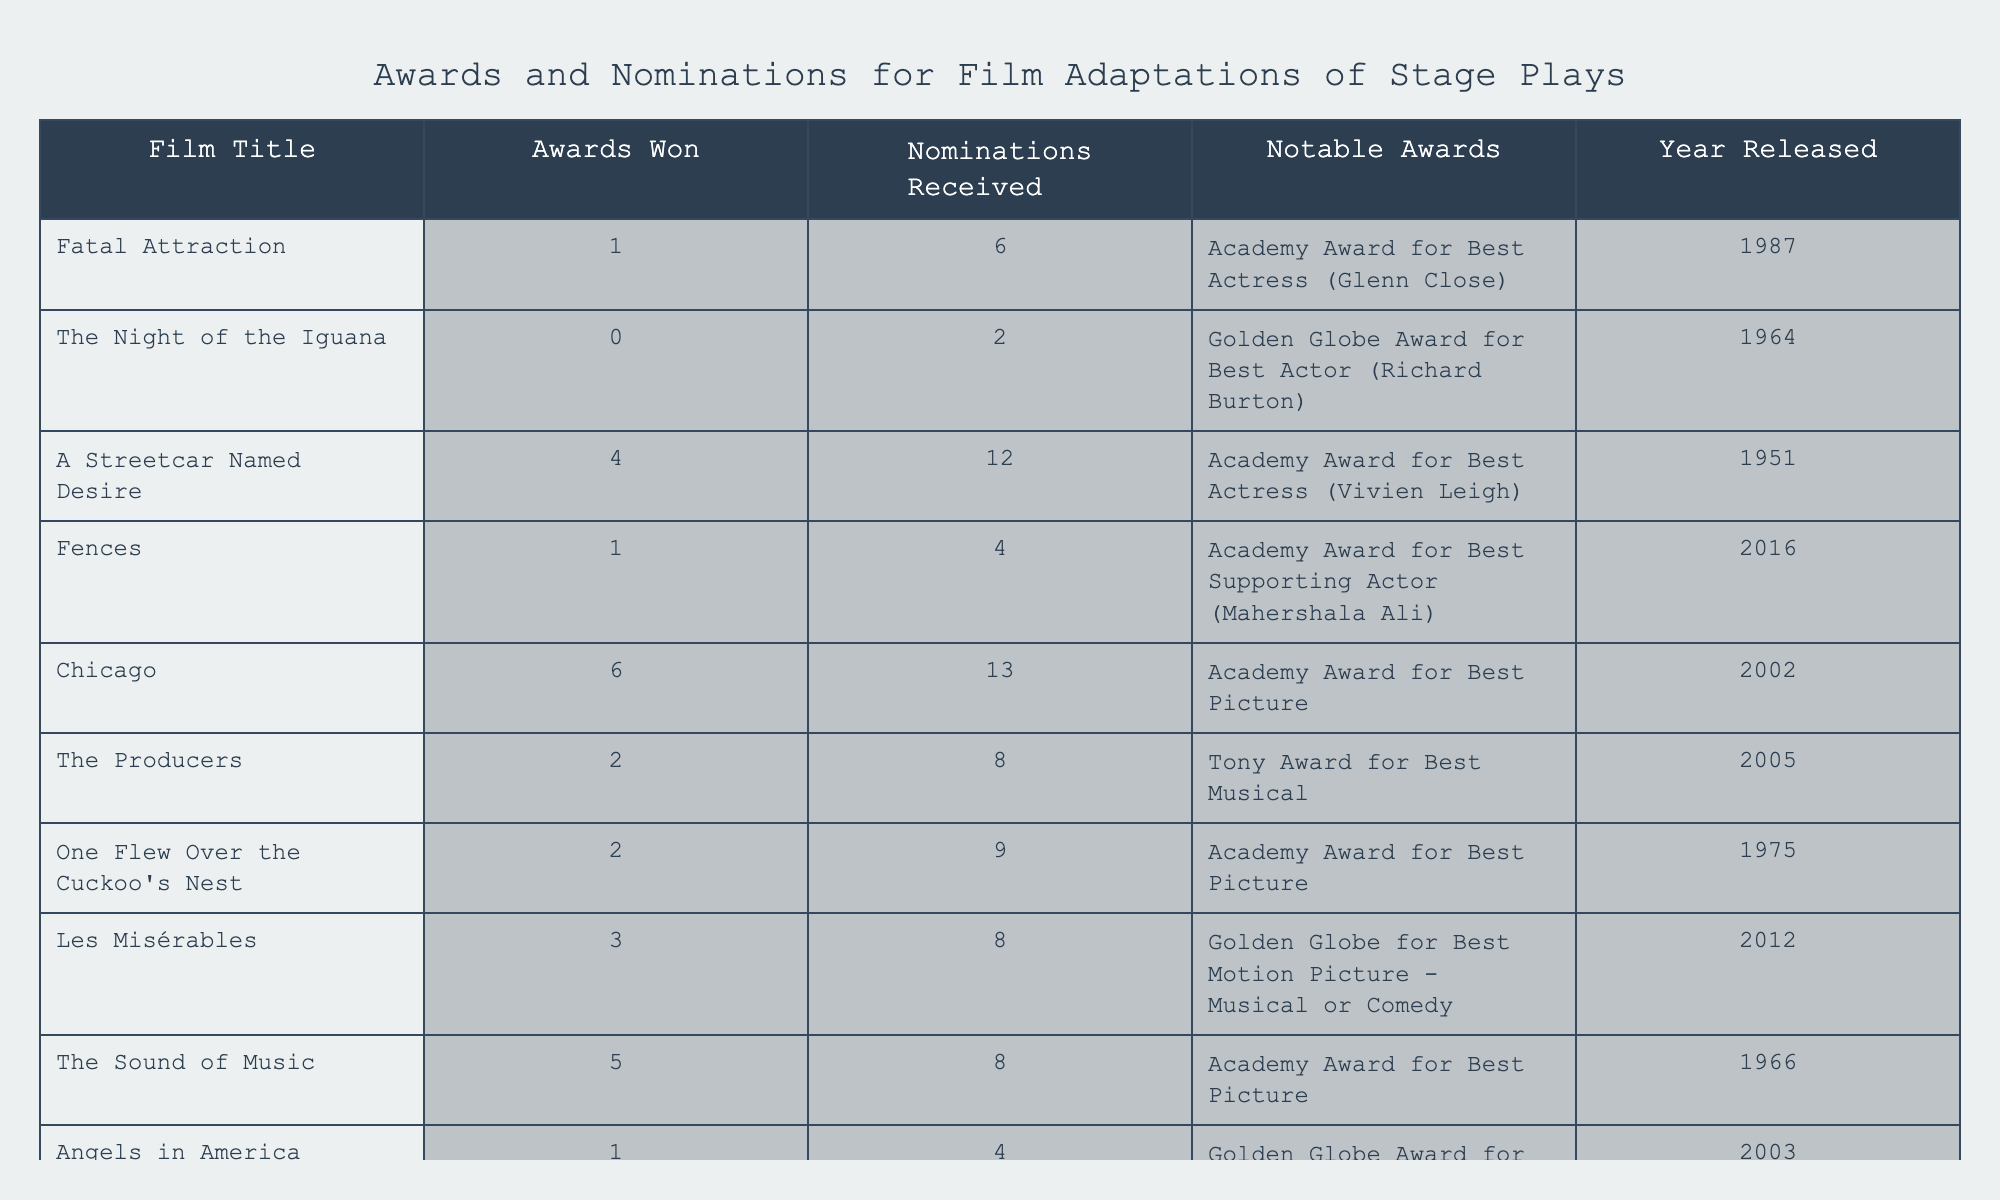What film adaptation has the most awards won? By examining the "Awards Won" column, "Chicago" has won the highest number with 6 awards.
Answer: Chicago Which film adaptation received an Academy Award for Best Actress? Looking at the "Notable Awards" column, "A Streetcar Named Desire" with Vivien Leigh is the only film adaptation that received this specific award.
Answer: A Streetcar Named Desire What is the total number of nominations received by the films listed? Adding the "Nominations Received" together: 6 + 2 + 12 + 4 + 13 + 8 + 9 + 8 + 8 + 4 = 76.
Answer: 76 Did "Les Misérables" win any awards? Referring to the "Awards Won", "Les Misérables" shows 3 awards won, which means it did win awards.
Answer: Yes Which film adaptations received a total of 4 nominations or fewer? By evaluating the "Nominations Received" column, we find "The Night of the Iguana" (2), "Fences" (4), and "Angels in America" (4), totaling three films fitting this criteria.
Answer: 3 What is the ratio of awards won to nominations received for "Fatal Attraction"? The ratio for "Fatal Attraction" is calculated as 1 award won to 6 nominations received, which simplifies to 1:6.
Answer: 1:6 Which film had the greatest number of nominations without winning any awards? "The Night of the Iguana" had 2 nominations and did not win any awards, making it the film with the greatest number of nominations without any wins.
Answer: The Night of the Iguana How many films won exactly 2 awards? By checking the "Awards Won" column, we see that "The Producers" and "One Flew Over the Cuckoo's Nest" each won exactly 2 awards, giving us a total of 2 films.
Answer: 2 What notable award did "Chicago" receive? The notable award received by "Chicago" is the Academy Award for Best Picture, as listed in the corresponding column.
Answer: Academy Award for Best Picture Which film adaptations had more nominations than "Angels in America"? Comparing "Angels in America" (4 nominations) with other films shows that "Chicago" (13), "A Streetcar Named Desire" (12), "One Flew Over the Cuckoo's Nest" (9), and "Les Misérables" (8) all had more nominations.
Answer: 4 